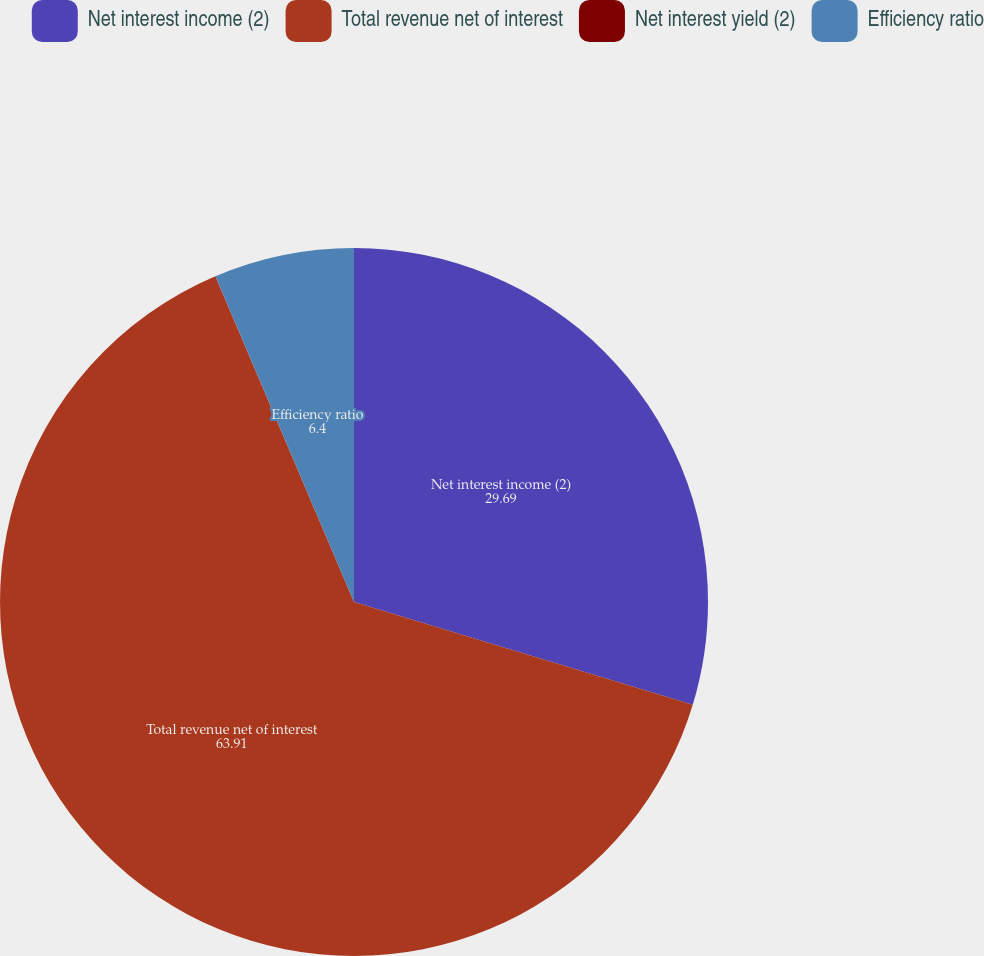Convert chart to OTSL. <chart><loc_0><loc_0><loc_500><loc_500><pie_chart><fcel>Net interest income (2)<fcel>Total revenue net of interest<fcel>Net interest yield (2)<fcel>Efficiency ratio<nl><fcel>29.69%<fcel>63.91%<fcel>0.01%<fcel>6.4%<nl></chart> 